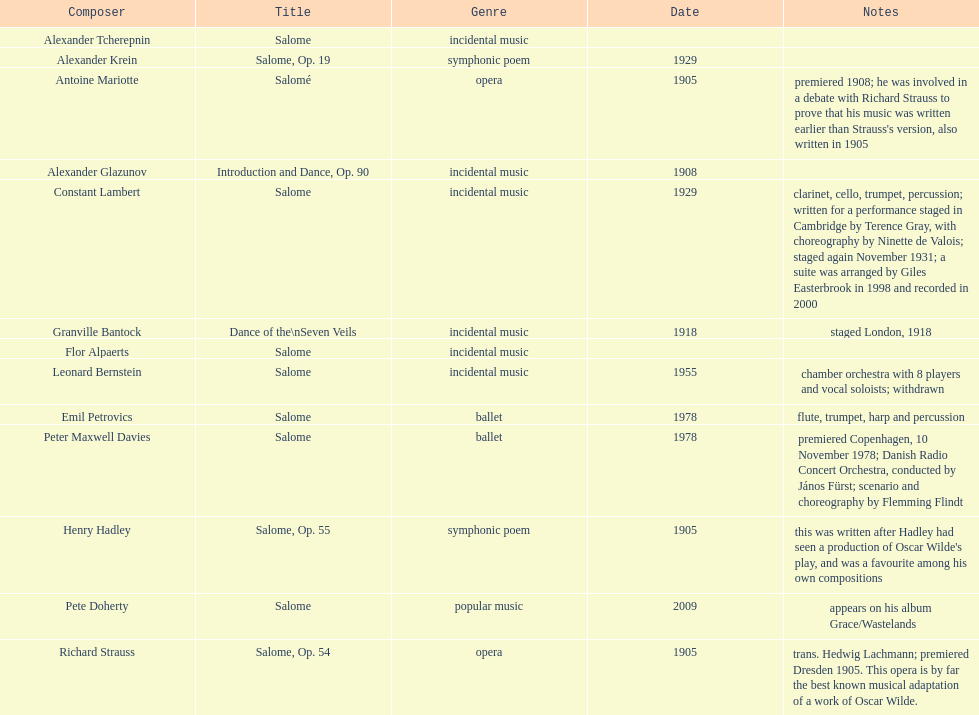I'm looking to parse the entire table for insights. Could you assist me with that? {'header': ['Composer', 'Title', 'Genre', 'Date', 'Notes'], 'rows': [['Alexander\xa0Tcherepnin', 'Salome', 'incidental music', '', ''], ['Alexander Krein', 'Salome, Op. 19', 'symphonic poem', '1929', ''], ['Antoine Mariotte', 'Salomé', 'opera', '1905', "premiered 1908; he was involved in a debate with Richard Strauss to prove that his music was written earlier than Strauss's version, also written in 1905"], ['Alexander Glazunov', 'Introduction and Dance, Op. 90', 'incidental music', '1908', ''], ['Constant Lambert', 'Salome', 'incidental music', '1929', 'clarinet, cello, trumpet, percussion; written for a performance staged in Cambridge by Terence Gray, with choreography by Ninette de Valois; staged again November 1931; a suite was arranged by Giles Easterbrook in 1998 and recorded in 2000'], ['Granville Bantock', 'Dance of the\\nSeven Veils', 'incidental music', '1918', 'staged London, 1918'], ['Flor Alpaerts', 'Salome', 'incidental\xa0music', '', ''], ['Leonard Bernstein', 'Salome', 'incidental music', '1955', 'chamber orchestra with 8 players and vocal soloists; withdrawn'], ['Emil Petrovics', 'Salome', 'ballet', '1978', 'flute, trumpet, harp and percussion'], ['Peter\xa0Maxwell\xa0Davies', 'Salome', 'ballet', '1978', 'premiered Copenhagen, 10 November 1978; Danish Radio Concert Orchestra, conducted by János Fürst; scenario and choreography by Flemming Flindt'], ['Henry Hadley', 'Salome, Op. 55', 'symphonic poem', '1905', "this was written after Hadley had seen a production of Oscar Wilde's play, and was a favourite among his own compositions"], ['Pete Doherty', 'Salome', 'popular music', '2009', 'appears on his album Grace/Wastelands'], ['Richard Strauss', 'Salome, Op. 54', 'opera', '1905', 'trans. Hedwig Lachmann; premiered Dresden 1905. This opera is by far the best known musical adaptation of a work of Oscar Wilde.']]} Which composer produced his title after 2001? Pete Doherty. 